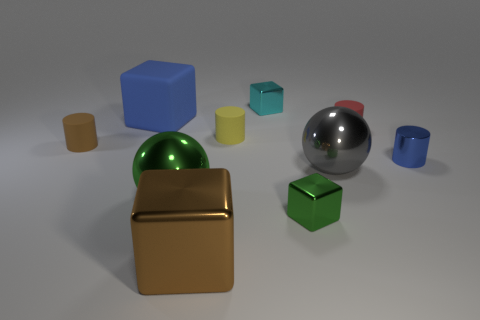What can you tell me about the lighting and shadows in the scene? The lighting in the scene is soft and diffused, creating gentle shadows on the ground beneath each object. The direction of the shadows indicates a single light source from above at a slight angle. 